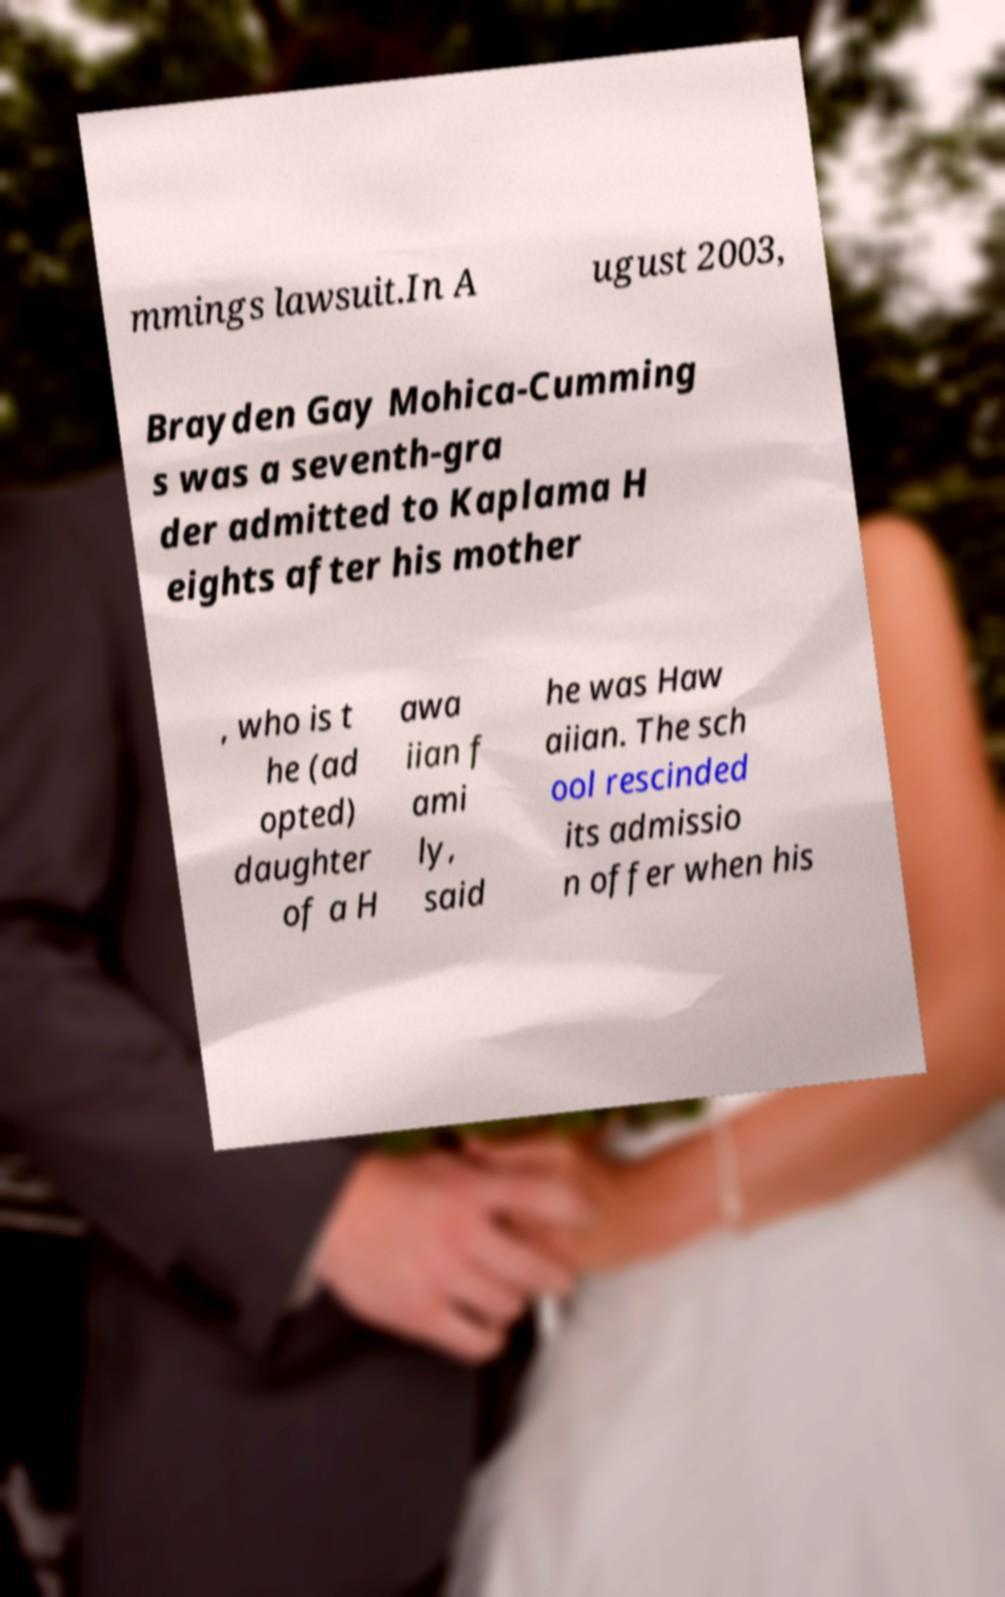Please read and relay the text visible in this image. What does it say? mmings lawsuit.In A ugust 2003, Brayden Gay Mohica-Cumming s was a seventh-gra der admitted to Kaplama H eights after his mother , who is t he (ad opted) daughter of a H awa iian f ami ly, said he was Haw aiian. The sch ool rescinded its admissio n offer when his 